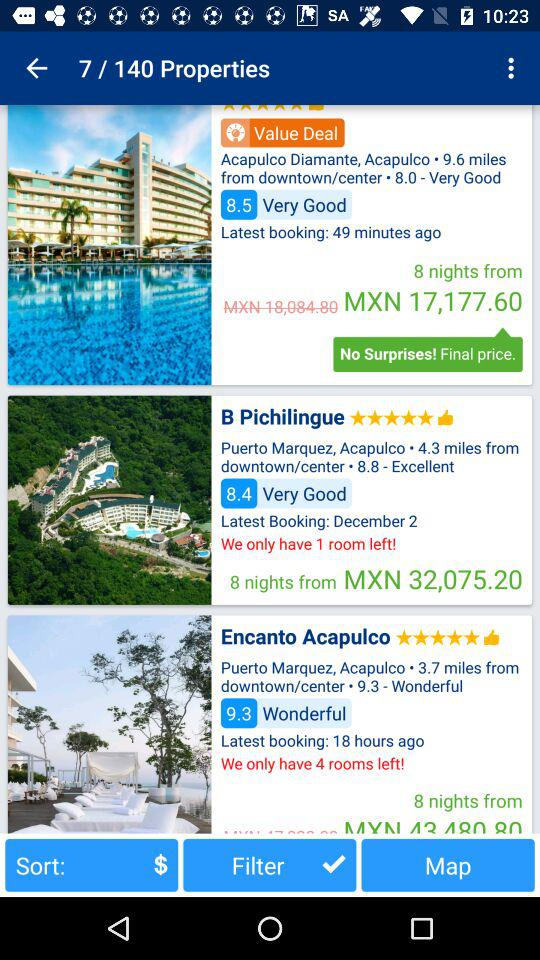When was the last booking done for "B Pichilingue"? The last booking for "B Pichilingue" was done on December 2. 